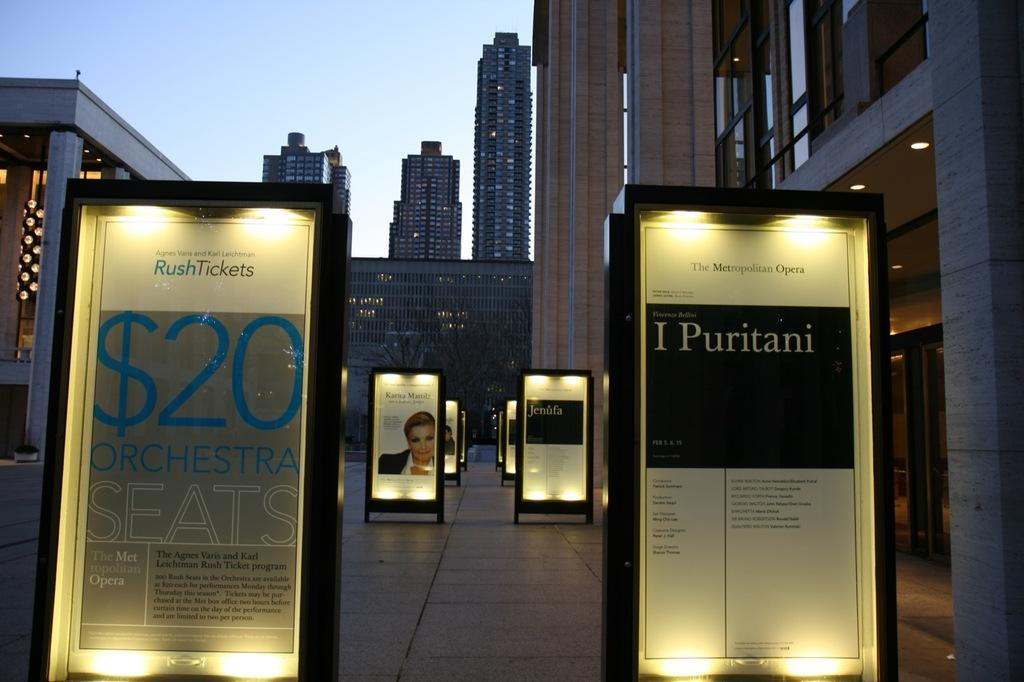What is present on the ground in the image? There are hoardings on the ground. What can be seen in the background of the image? There are buildings, poles, windows, lights on the roof top, and doors in the background. What part of the natural environment is visible in the image? The sky is visible in the image. Can you see a notebook being used by someone in the image? There is no notebook present in the image. Is there a bucket visible in the image? There is no bucket present in the image. 